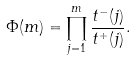<formula> <loc_0><loc_0><loc_500><loc_500>\Phi ( m ) = \prod _ { j = 1 } ^ { m } \frac { t ^ { - } ( j ) } { t ^ { + } ( j ) } .</formula> 